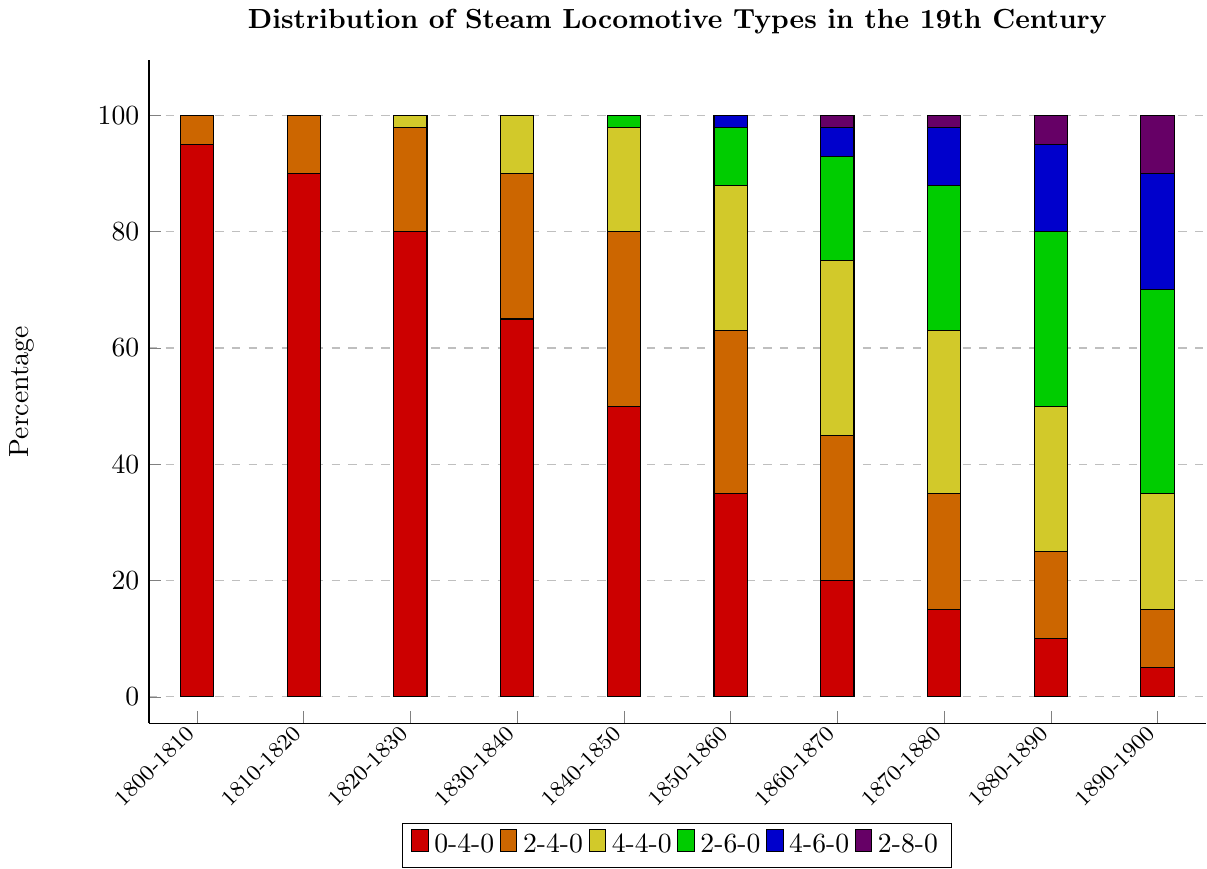What locomotive type was used the most in the 1800-1810 decade? The figure shows the highest bar for the 0-4-0 type in the 1800-1810 decade, indicating that this type was used the most.
Answer: 0-4-0 Which locomotive type shows a steady increase in usage from 1800-1900? By examining the heights of the different colored bars representing each locomotive type, it is apparent that the 4-6-0 type steadily increases as the decades progress.
Answer: 4-6-0 In which decade did the 4-4-0 type surpass the usage of the 0-4-0 type? By comparing the heights of the yellow and red bars across the decades, the yellow bar (4-4-0) surpasses the red bar (0-4-0) from the 1860-1870 decade onwards.
Answer: 1860-1870 Which decade saw the highest percentage of locomotive type diversification? The decade where the most distinct colors (locomotive types) are present in the stacked bar is from 1890-1900.
Answer: 1890-1900 How many locomotive types were first introduced by the 1850-1860 decade? By comparing the introduction of new bar colors up to the 1850-1860 decade, three additional types (4-4-0, 2-6-0, 4-6-0) were introduced since 1800-1810.
Answer: 3 Which two locomotive types had the smallest and largest usage difference in the 1840-1850 decade? By comparing the heights of the bars in the 1840-1850 decade, the smallest difference is between the 4-4-0 (18%) and 2-6-0 (2%) types, and the largest is between the 0-4-0 (50%) and any other type.
Answer: Smallest: 4-4-0 and 2-6-0, Largest: 0-4-0 and others What is the combined percentage usage of 4-6-0 and 2-8-0 types in the 1890-1900 decade? The blue bar for 4-6-0 is 20%, and the violet bar for 2-8-0 is 10%, summing to 30%.
Answer: 30% Which decade shows the largest relative decline in the use of the 0-4-0 type locomotives? The largest decrease in the height of the red bar occurs between the 1820-1830 and the 1830-1840 decades, a drop from 80% to 65%.
Answer: 1820-1830 to 1830-1840 How does the usage distribution of the 2-4-0 type change between 1800-1810 and 1890-1900? The orange bar shows an increase from 5% in 1800-1810 to 10% in 1890-1900.
Answer: Increased From which decade did the 4-6-0 and 2-8-0 locomotive types start being used? From the progression in colors, the blue bar (4-6-0) appears in the 1850-1860 decade, and the violet bar (2-8-0) appears in the 1860-1870 decade.
Answer: 1850-1860 for 4-6-0, 1860-1870 for 2-8-0 